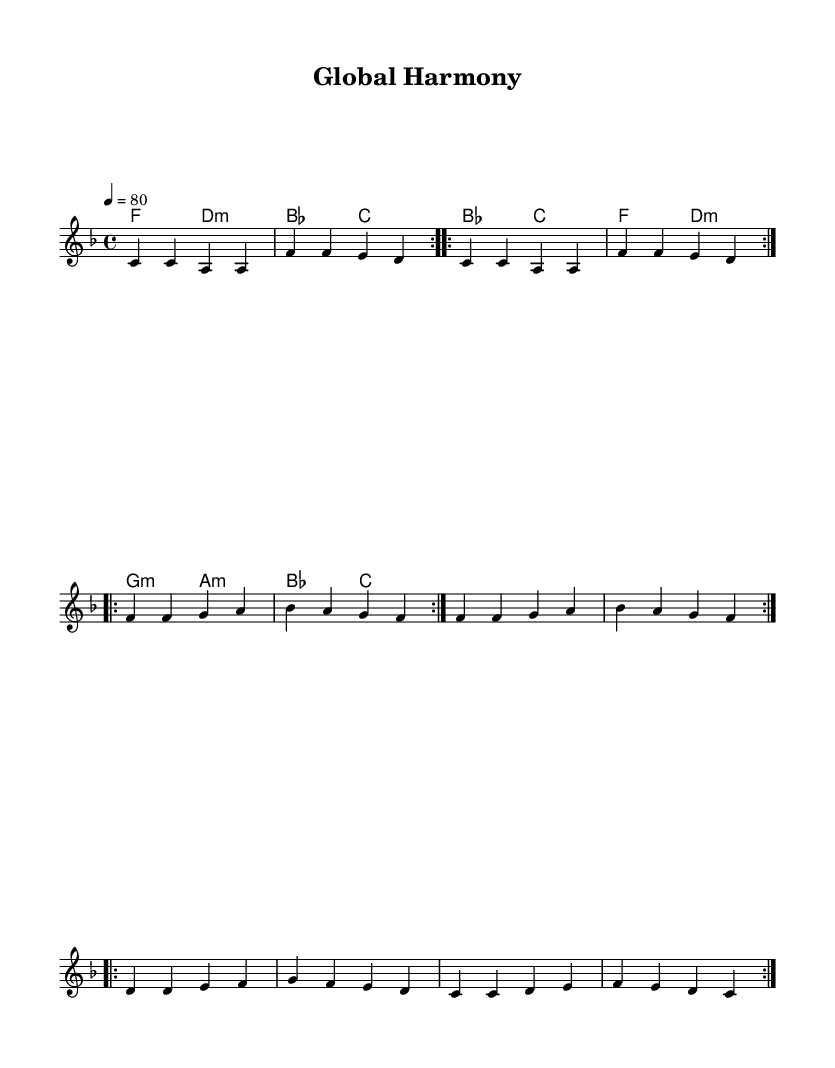What is the key signature of this music? The key signature is F major, which contains one flat (B flat). This can be identified from the key signature notation at the beginning of the score.
Answer: F major What is the time signature of the piece? The time signature is 4/4, indicated at the beginning of the score. This means there are four beats in a measure, and a quarter note receives one beat.
Answer: 4/4 What is the tempo marking for this music? The tempo marking indicates a speed of 80 beats per minute. This can be found in the tempo instruction at the beginning of the score.
Answer: 80 How many times is the chorus repeated? The chorus is included once in the score, as discerned from the structure of the lyrics and placed within the repeats of the melody.
Answer: Once What languages are used in the lyrics? The lyrics are written in English, Spanish, French, and Chinese. This can be observed in each verse and the bridge.
Answer: English, Spanish, French, Chinese What kind of harmony is predominantly used in the piece? The harmonies are primarily diatonic chords from the F major scale, including major and minor chords, as specified in the chord structure.
Answer: Diatonic chords What style does the song reflect based on its lyrics and structure? The song reflects a Rhythm and Blues style, reinforced by its emotional lyrics about unity and love, often characteristic of the genre.
Answer: Rhythm and Blues 